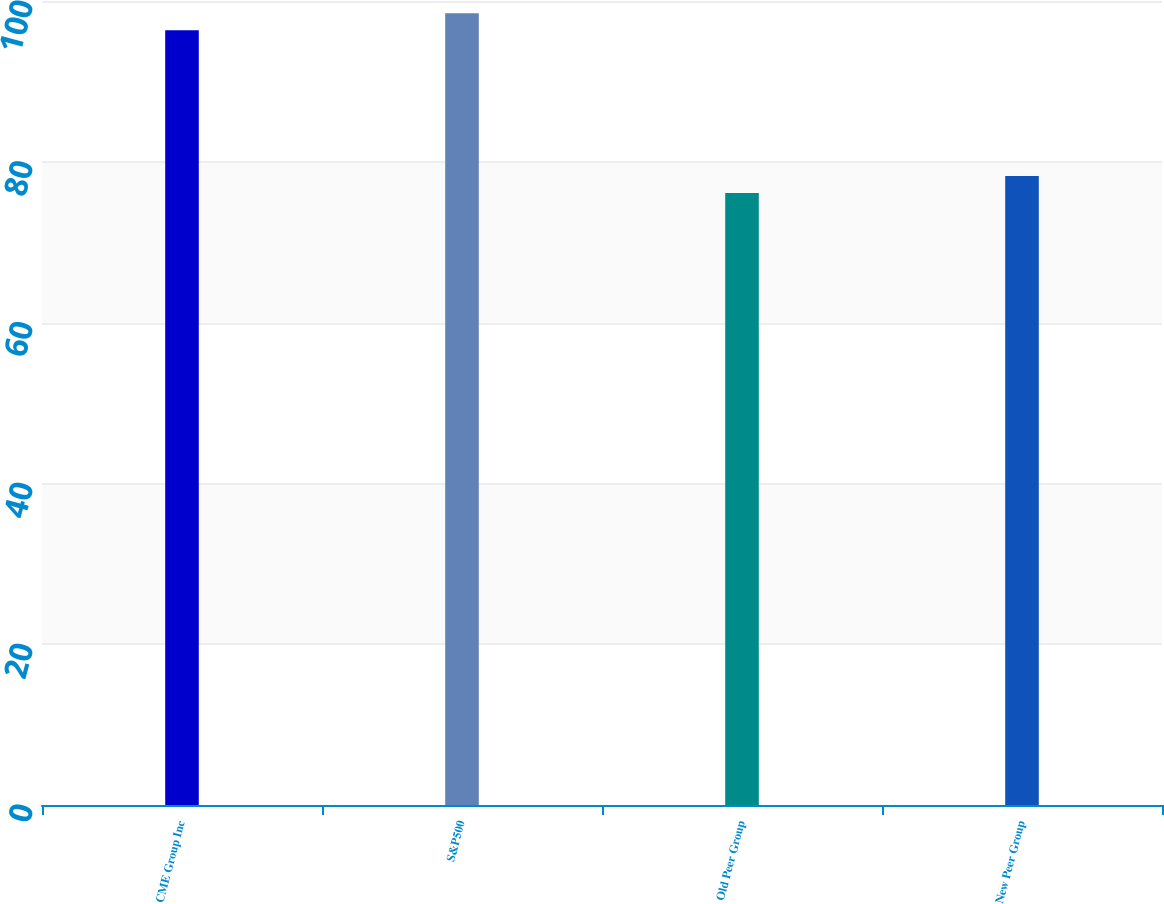<chart> <loc_0><loc_0><loc_500><loc_500><bar_chart><fcel>CME Group Inc<fcel>S&P500<fcel>Old Peer Group<fcel>New Peer Group<nl><fcel>96.37<fcel>98.49<fcel>76.11<fcel>78.23<nl></chart> 